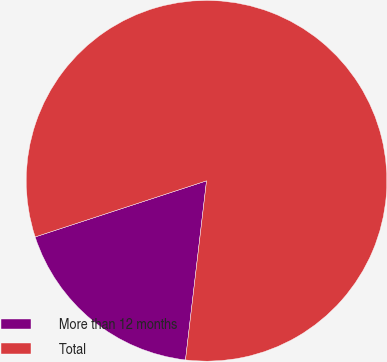Convert chart to OTSL. <chart><loc_0><loc_0><loc_500><loc_500><pie_chart><fcel>More than 12 months<fcel>Total<nl><fcel>18.1%<fcel>81.9%<nl></chart> 